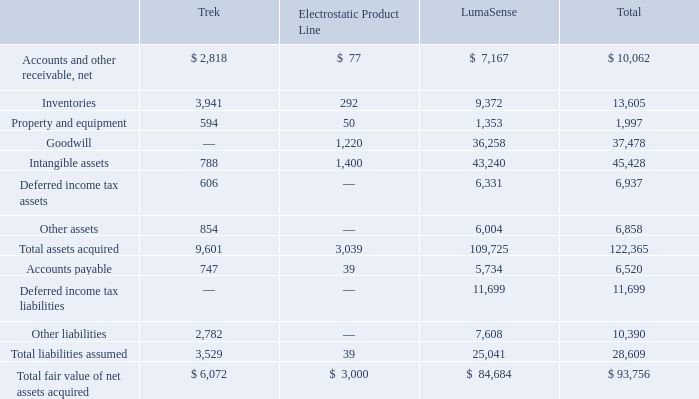ADVANCED ENERGY INDUSTRIES, INC. NOTES TO CONSOLIDATED FINANCIAL STATEMENTS – (continued) (in thousands, except per share amounts)
The final fair values of the assets acquired and liabilities assumed from our acquisitions in 2018 are as follows:
What was the fair value of Inventories from Trek?
Answer scale should be: thousand. 3,941. What was the fair value of  Property and equipment from LumaSense?
Answer scale should be: thousand. 1,353. What was the fair value of Goodwill from Electrostatic Product Line?
Answer scale should be: thousand. 1,220. What was the difference between the fair value of Inventories between Trek and LumaSense?
Answer scale should be: thousand. 9,372-3,941
Answer: 5431. What was the difference between the total fair value of Inventories and Goodwill?
Answer scale should be: thousand. 37,478-13,605
Answer: 23873. What is the sum of the 3 highest total assets types?
Answer scale should be: thousand. 13,605+37,478+45,428
Answer: 96511. 